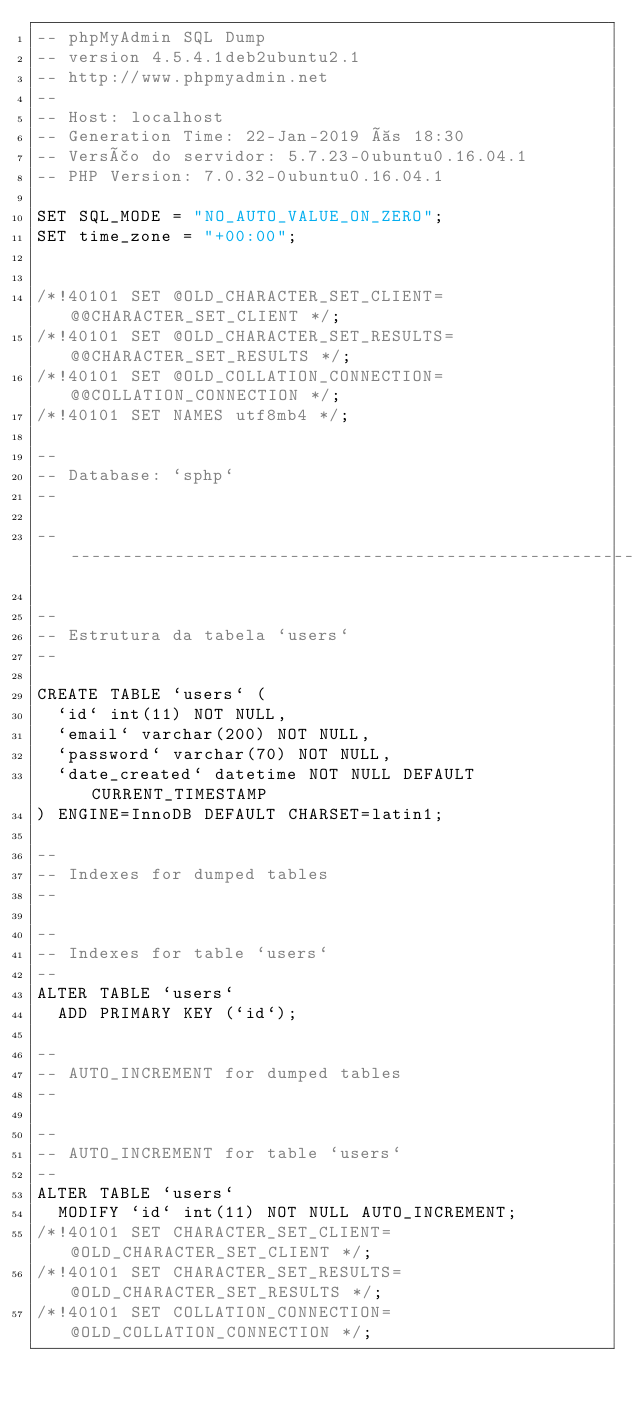Convert code to text. <code><loc_0><loc_0><loc_500><loc_500><_SQL_>-- phpMyAdmin SQL Dump
-- version 4.5.4.1deb2ubuntu2.1
-- http://www.phpmyadmin.net
--
-- Host: localhost
-- Generation Time: 22-Jan-2019 às 18:30
-- Versão do servidor: 5.7.23-0ubuntu0.16.04.1
-- PHP Version: 7.0.32-0ubuntu0.16.04.1

SET SQL_MODE = "NO_AUTO_VALUE_ON_ZERO";
SET time_zone = "+00:00";


/*!40101 SET @OLD_CHARACTER_SET_CLIENT=@@CHARACTER_SET_CLIENT */;
/*!40101 SET @OLD_CHARACTER_SET_RESULTS=@@CHARACTER_SET_RESULTS */;
/*!40101 SET @OLD_COLLATION_CONNECTION=@@COLLATION_CONNECTION */;
/*!40101 SET NAMES utf8mb4 */;

--
-- Database: `sphp`
--

-- --------------------------------------------------------

--
-- Estrutura da tabela `users`
--

CREATE TABLE `users` (
  `id` int(11) NOT NULL,
  `email` varchar(200) NOT NULL,
  `password` varchar(70) NOT NULL,
  `date_created` datetime NOT NULL DEFAULT CURRENT_TIMESTAMP
) ENGINE=InnoDB DEFAULT CHARSET=latin1;

--
-- Indexes for dumped tables
--

--
-- Indexes for table `users`
--
ALTER TABLE `users`
  ADD PRIMARY KEY (`id`);

--
-- AUTO_INCREMENT for dumped tables
--

--
-- AUTO_INCREMENT for table `users`
--
ALTER TABLE `users`
  MODIFY `id` int(11) NOT NULL AUTO_INCREMENT;
/*!40101 SET CHARACTER_SET_CLIENT=@OLD_CHARACTER_SET_CLIENT */;
/*!40101 SET CHARACTER_SET_RESULTS=@OLD_CHARACTER_SET_RESULTS */;
/*!40101 SET COLLATION_CONNECTION=@OLD_COLLATION_CONNECTION */;
</code> 